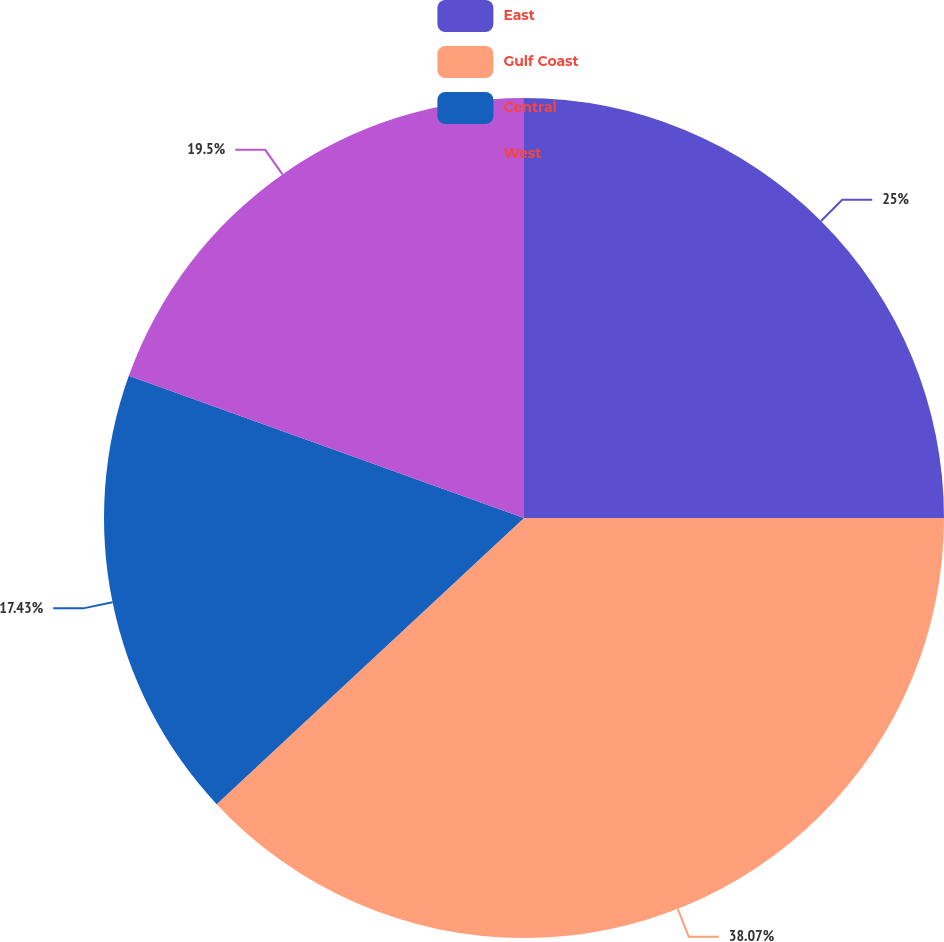<chart> <loc_0><loc_0><loc_500><loc_500><pie_chart><fcel>East<fcel>Gulf Coast<fcel>Central<fcel>West<nl><fcel>25.0%<fcel>38.06%<fcel>17.43%<fcel>19.5%<nl></chart> 